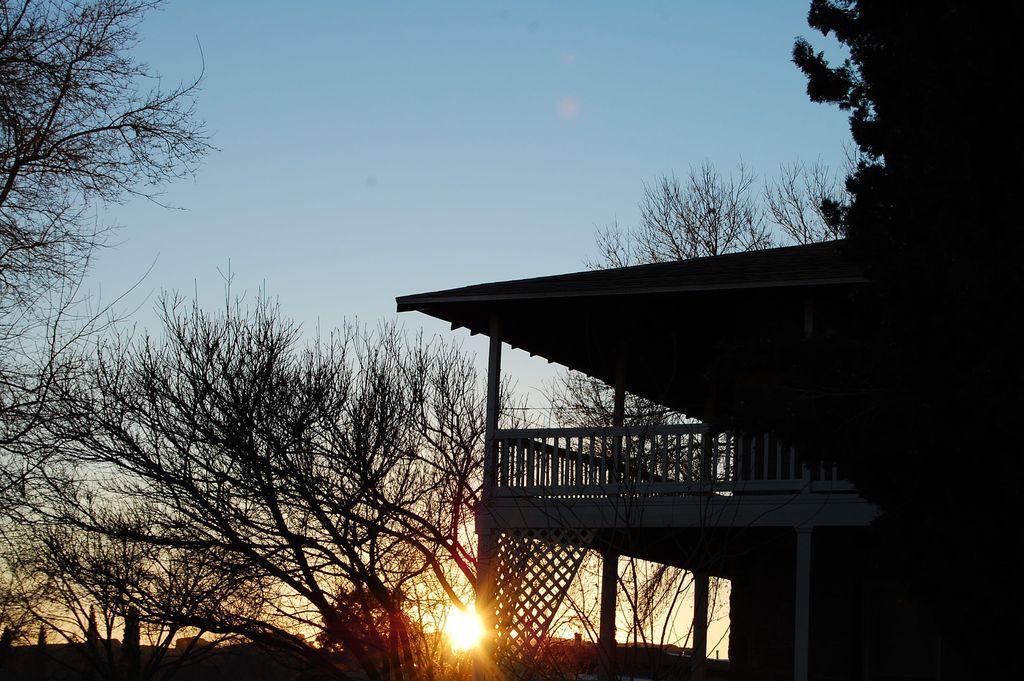Can you describe this image briefly? In this image, we can see some trees and sun. There is shelter on the right side of the image. There is a sky at the top of the image. 